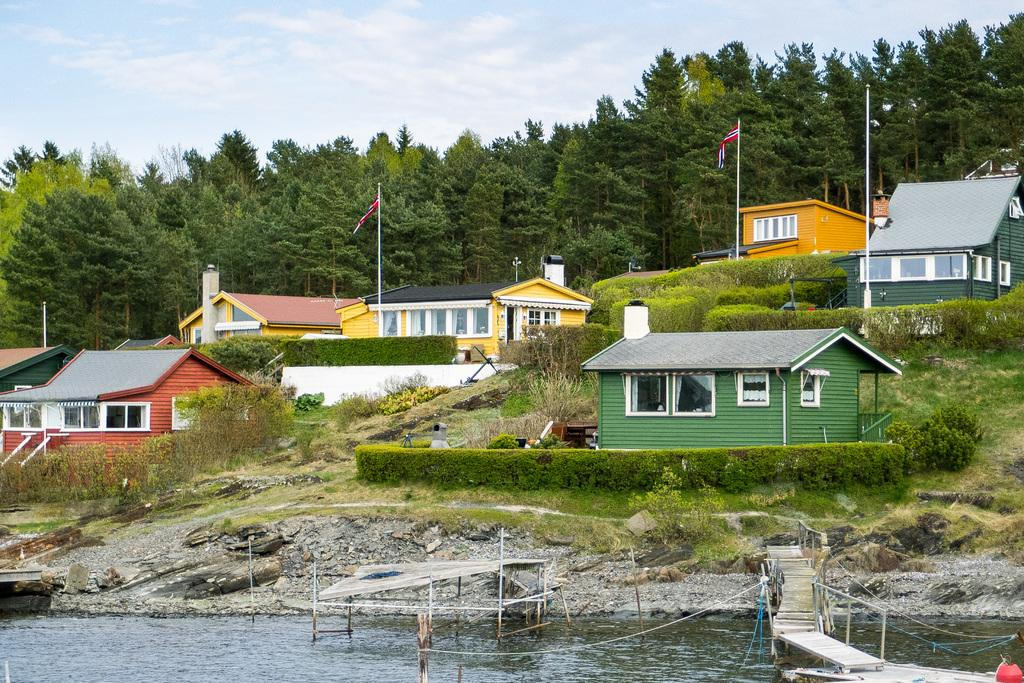What is the primary element in the image? There is water in the image. What structure can be seen crossing the water? There is a bridge in the image. What are the ropes used for in the image? The purpose of the ropes is not specified, but they are present in the image. What type of shelter is visible in the image? There is a tent in the image. What type of ground surface is visible in the image? Grass is visible in the image. What type of vegetation is present in the image? Plants are present in the image. What type of human-made structures can be seen in the image? Houses are visible in the image. What vertical structure is present in the image? There is a flagpole in the image. What type of natural features are present in the image? Trees are present in the image. What part of the natural environment is visible in the image? The sky is visible in the image. What type of location might the image depict? The image may have been taken near a lake. How many feet are required to stop the car in the image? There is no car present in the image, so it is not possible to determine how many feet are required to stop it. 